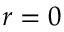<formula> <loc_0><loc_0><loc_500><loc_500>r = 0</formula> 